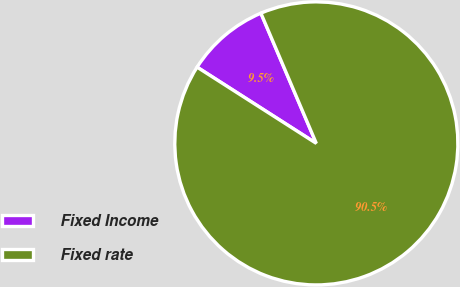Convert chart. <chart><loc_0><loc_0><loc_500><loc_500><pie_chart><fcel>Fixed Income<fcel>Fixed rate<nl><fcel>9.54%<fcel>90.46%<nl></chart> 